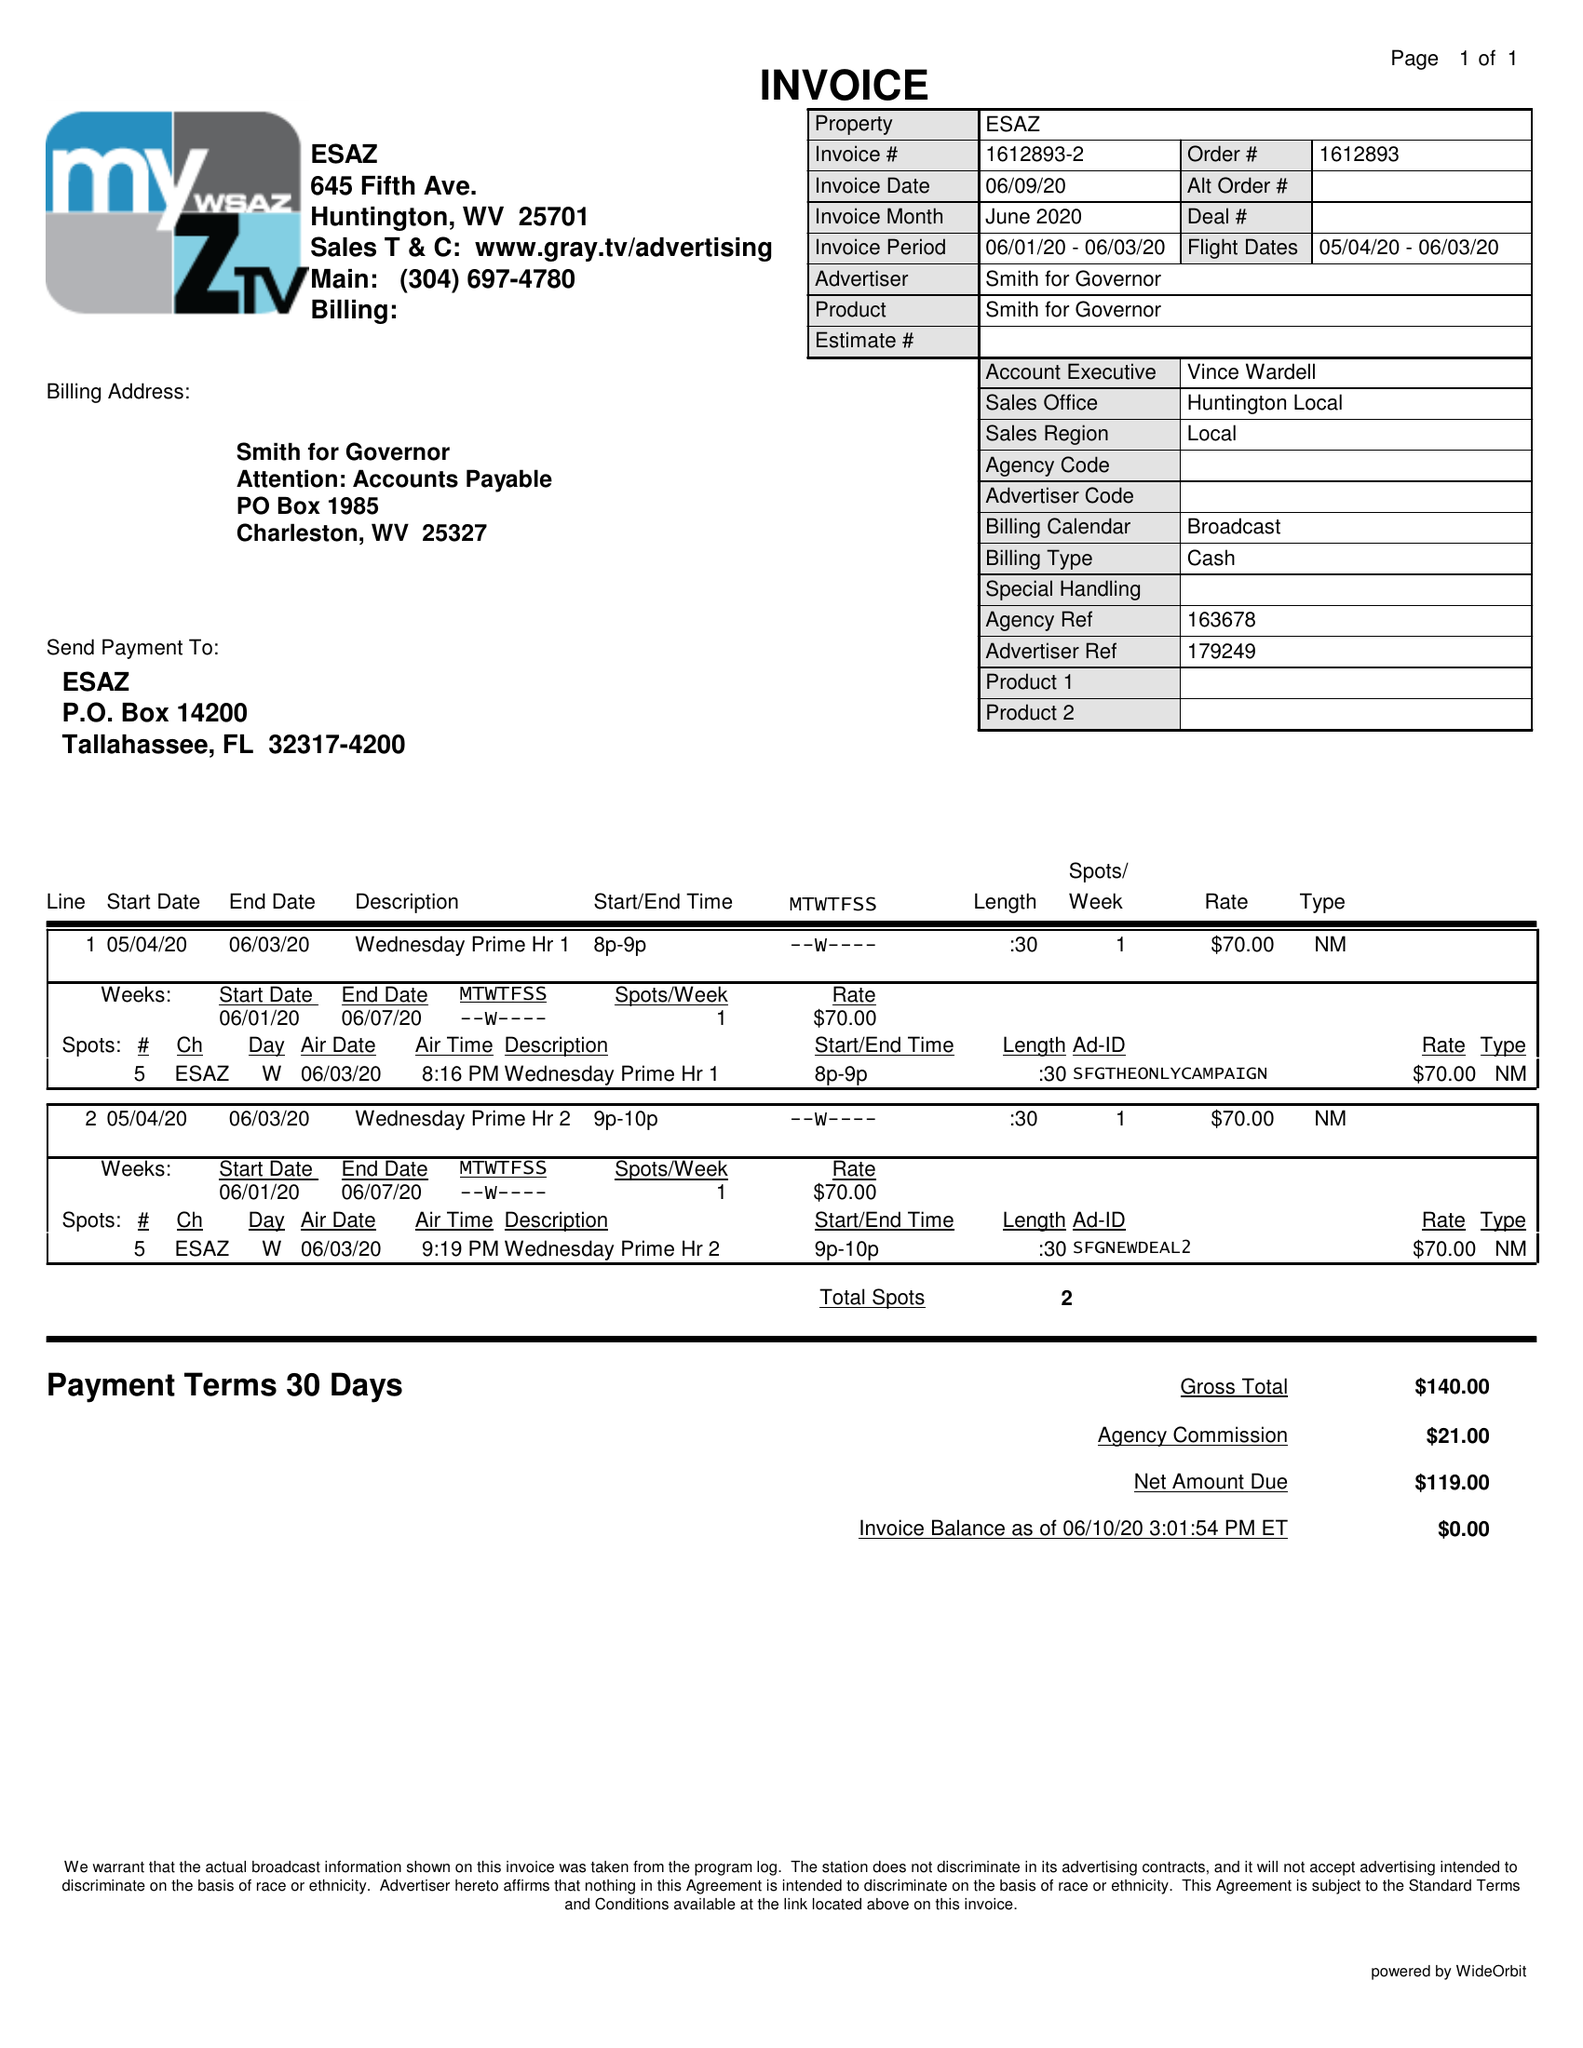What is the value for the flight_to?
Answer the question using a single word or phrase. 06/03/20 